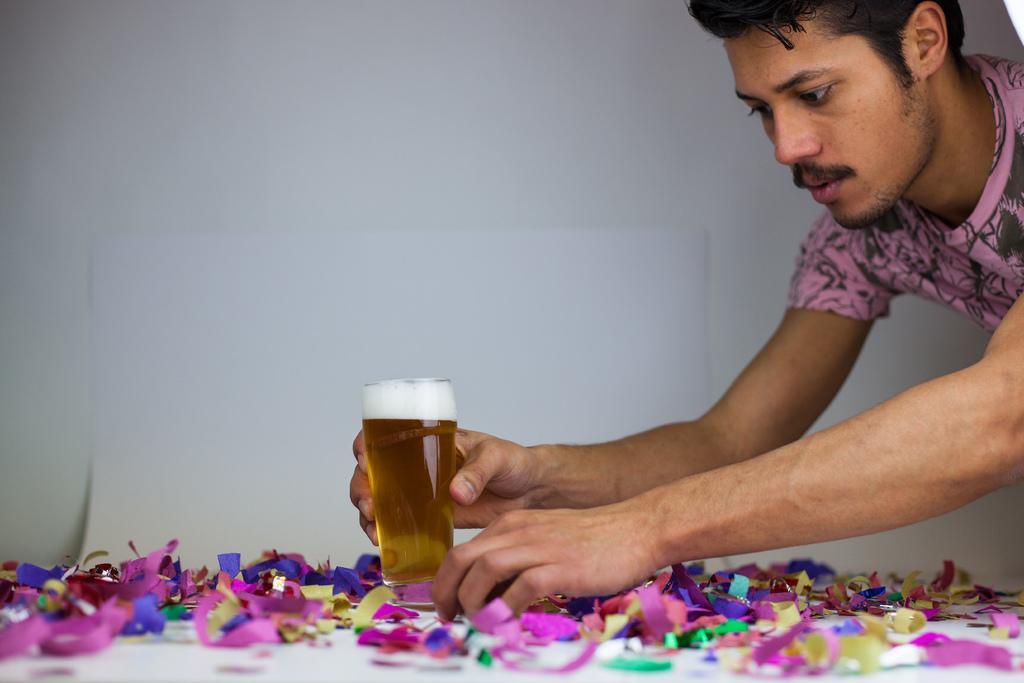Describe this image in one or two sentences. This image consists of a man who is on the left side, he is holding a glass in his hand. He is trying to place it down. 